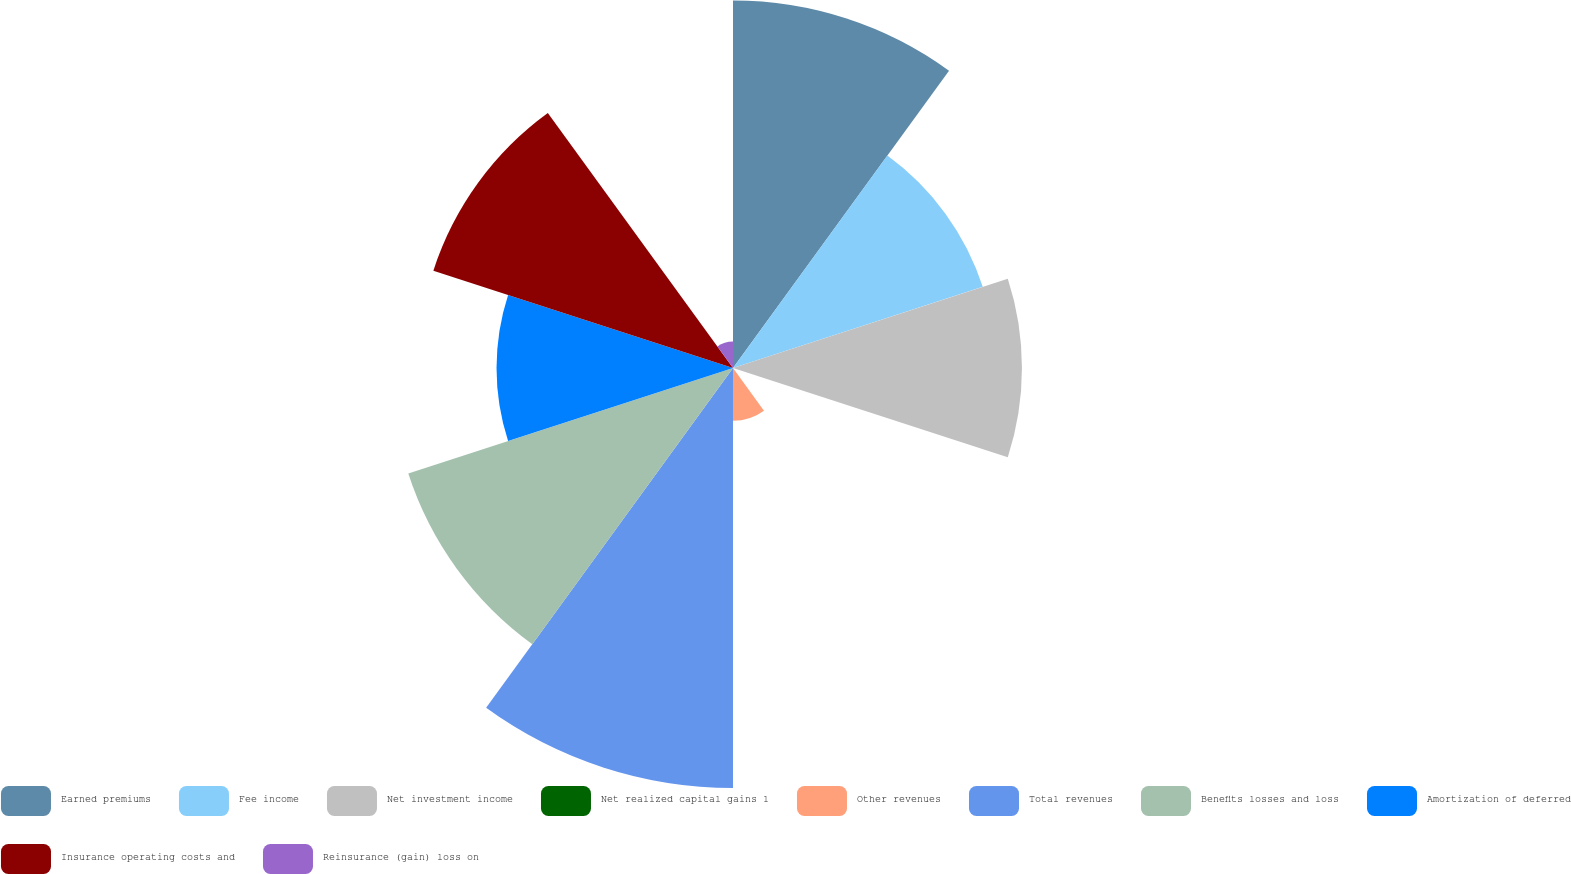<chart> <loc_0><loc_0><loc_500><loc_500><pie_chart><fcel>Earned premiums<fcel>Fee income<fcel>Net investment income<fcel>Net realized capital gains 1<fcel>Other revenues<fcel>Total revenues<fcel>Benefits losses and loss<fcel>Amortization of deferred<fcel>Insurance operating costs and<fcel>Reinsurance (gain) loss on<nl><fcel>15.9%<fcel>11.36%<fcel>12.5%<fcel>0.01%<fcel>2.28%<fcel>18.17%<fcel>14.77%<fcel>10.23%<fcel>13.63%<fcel>1.15%<nl></chart> 